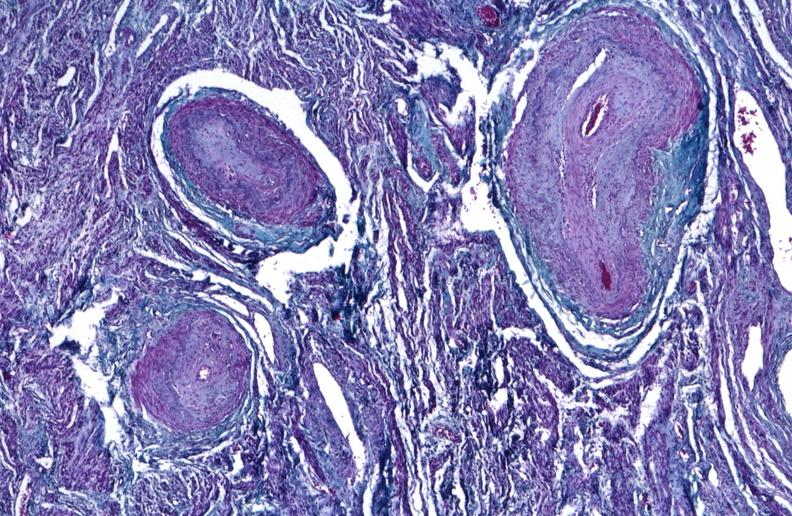does basal skull fracture show kidney, polyarteritis nodosa?
Answer the question using a single word or phrase. No 